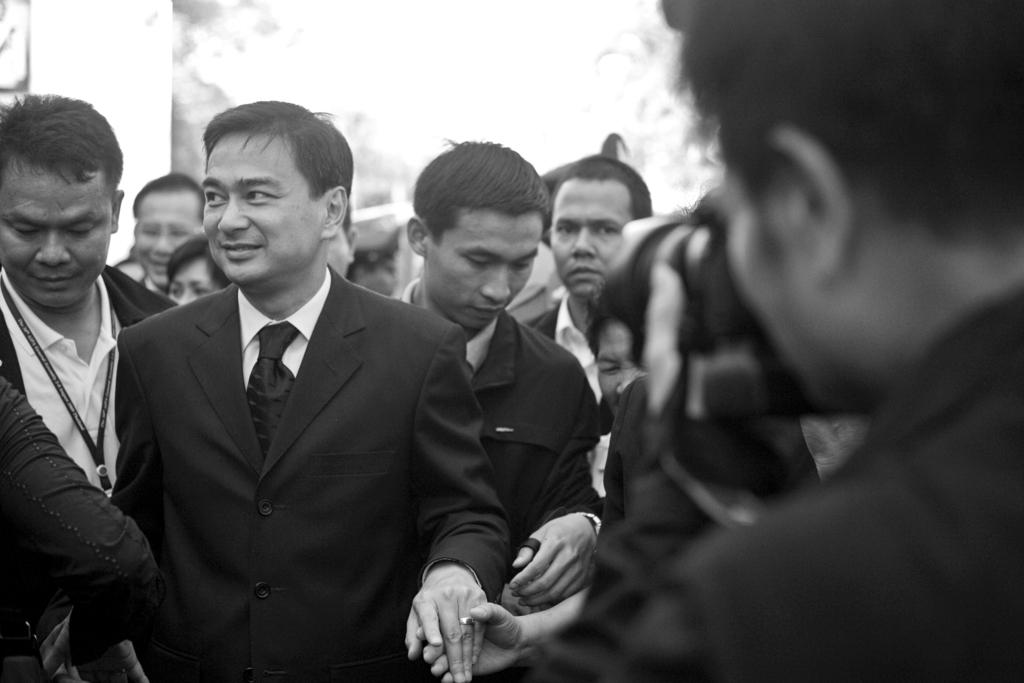How many people are in the image? There is a group of people in the image, but the exact number is not specified. What are the people in the image doing? The people in the image are standing. What type of stove can be seen in the image? There is no stove present in the image. How many matches are visible in the image? There are no matches visible in the image. 